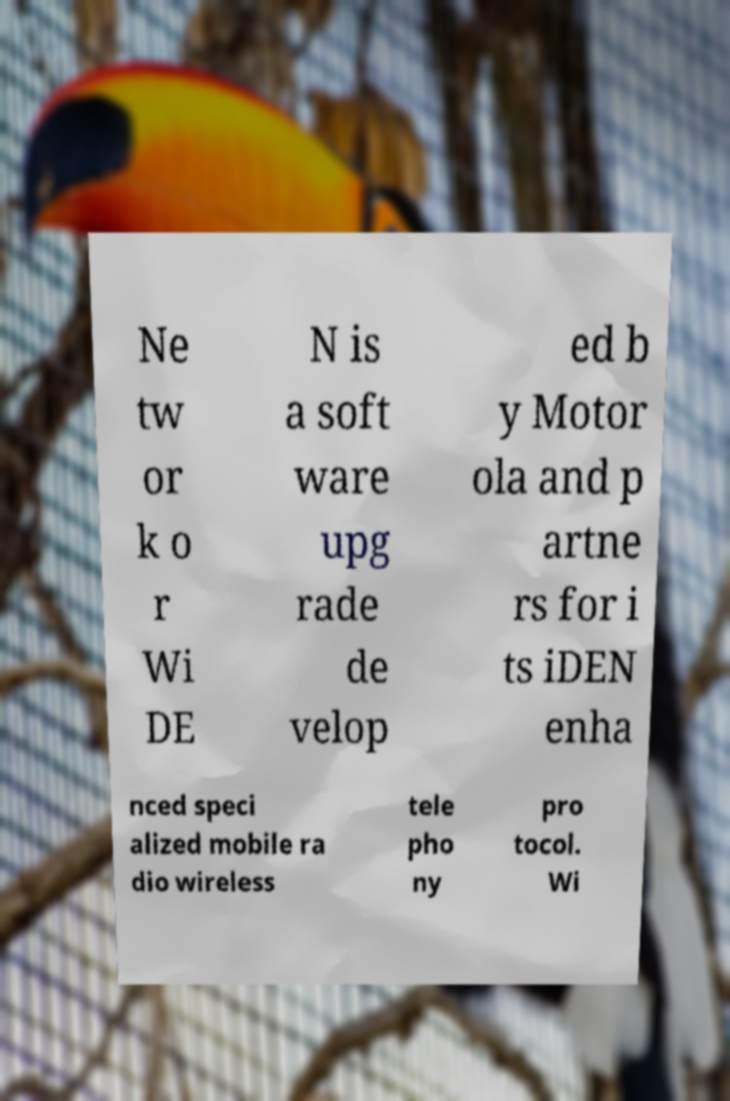Can you accurately transcribe the text from the provided image for me? Ne tw or k o r Wi DE N is a soft ware upg rade de velop ed b y Motor ola and p artne rs for i ts iDEN enha nced speci alized mobile ra dio wireless tele pho ny pro tocol. Wi 